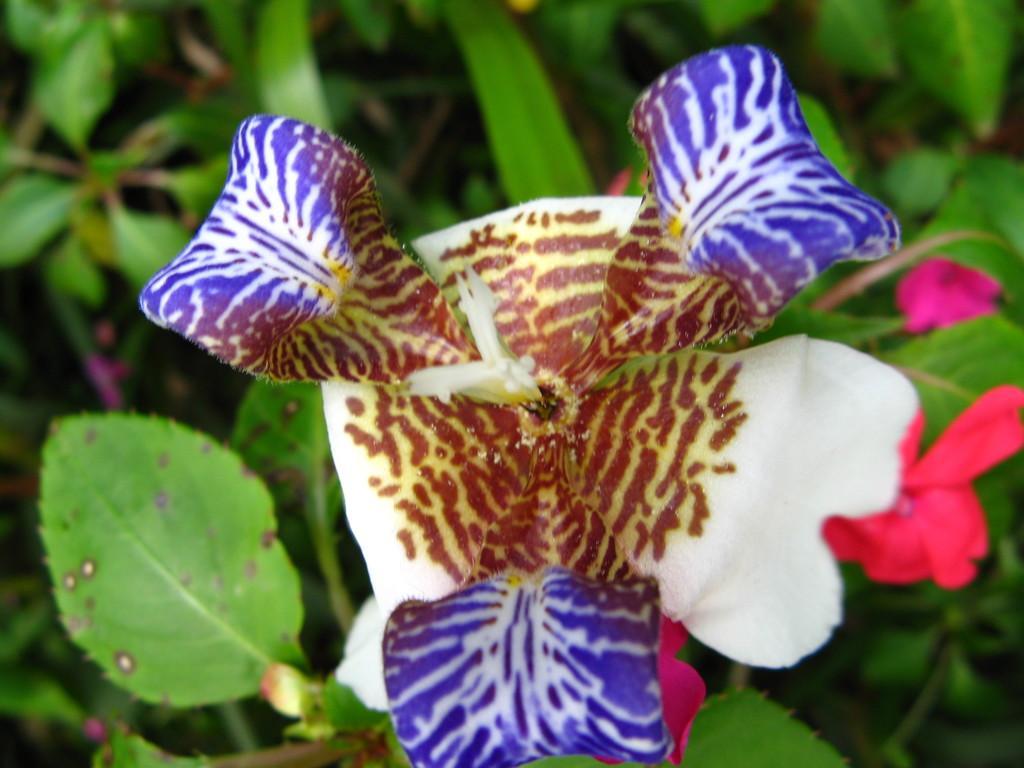Please provide a concise description of this image. In this image I can see a flower which is brown, white and purple in color. I can see few other flowers which are pink in color and few plants in the background. 